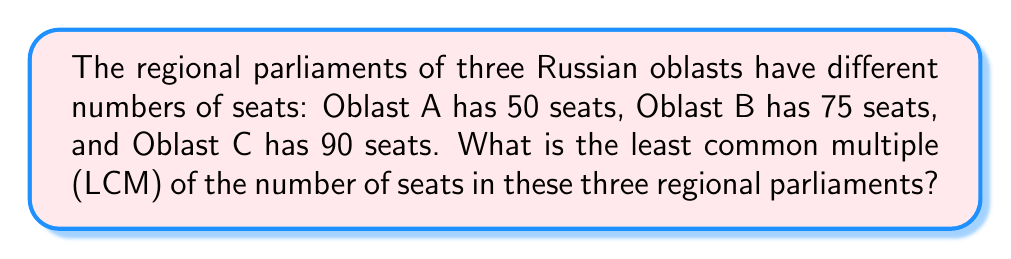Help me with this question. To find the least common multiple (LCM) of 50, 75, and 90, we'll follow these steps:

1. First, let's find the prime factorization of each number:
   
   $50 = 2 \times 5^2$
   $75 = 3 \times 5^2$
   $90 = 2 \times 3^2 \times 5$

2. The LCM will include the highest power of each prime factor from these factorizations:
   
   $LCM(50, 75, 90) = 2 \times 3^2 \times 5^2$

3. Now, let's calculate this:
   
   $2 \times 3^2 \times 5^2 = 2 \times 9 \times 25 = 18 \times 25 = 450$

Therefore, the least common multiple of the number of seats in these three regional parliaments is 450.
Answer: 450 